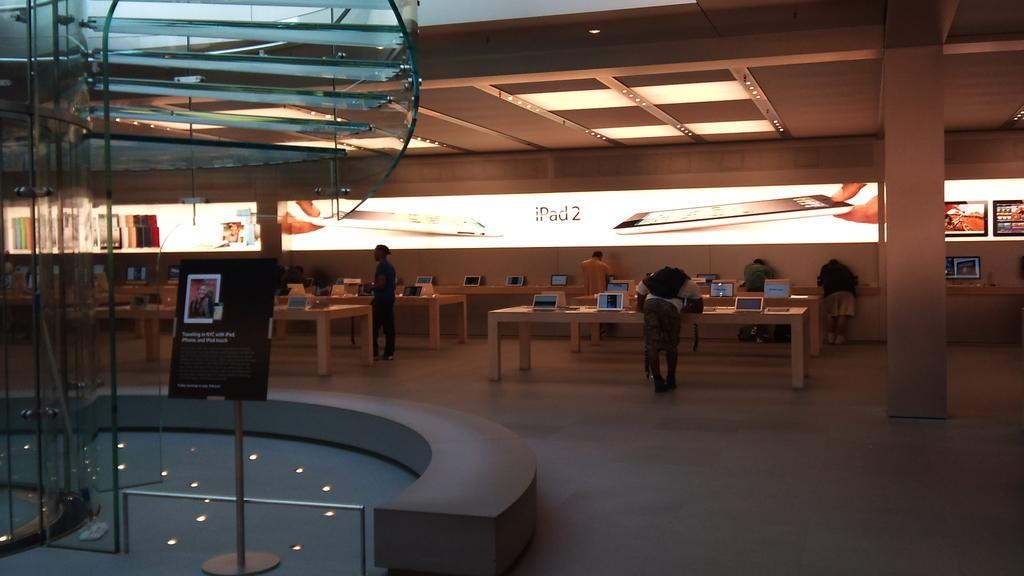How many persons are in the image? There are persons in the image, but the exact number is not specified. What are some of the persons doing in the image? Some of the persons are standing, and some of them are doing work. What electronic devices can be seen in the image? There are iPads on a table in the image. What type of screen is visible in the background of the image? There is a glass screen visible in the background of the image. What type of fang can be seen in the image? There is no fang present in the image. Can you tell me how fast the persons are running in the image? The persons are not running in the image; they are standing or doing work. 